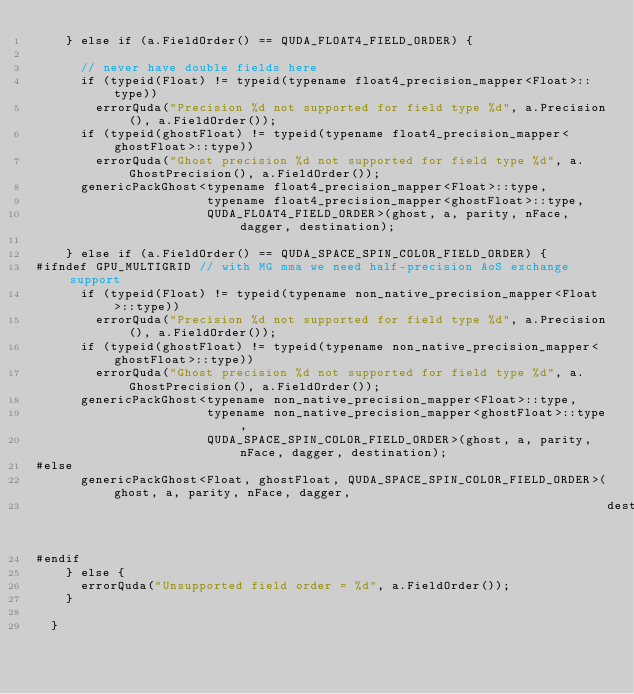<code> <loc_0><loc_0><loc_500><loc_500><_Cuda_>    } else if (a.FieldOrder() == QUDA_FLOAT4_FIELD_ORDER) {

      // never have double fields here
      if (typeid(Float) != typeid(typename float4_precision_mapper<Float>::type))
        errorQuda("Precision %d not supported for field type %d", a.Precision(), a.FieldOrder());
      if (typeid(ghostFloat) != typeid(typename float4_precision_mapper<ghostFloat>::type))
        errorQuda("Ghost precision %d not supported for field type %d", a.GhostPrecision(), a.FieldOrder());
      genericPackGhost<typename float4_precision_mapper<Float>::type,
                       typename float4_precision_mapper<ghostFloat>::type,
                       QUDA_FLOAT4_FIELD_ORDER>(ghost, a, parity, nFace, dagger, destination);

    } else if (a.FieldOrder() == QUDA_SPACE_SPIN_COLOR_FIELD_ORDER) {
#ifndef GPU_MULTIGRID // with MG mma we need half-precision AoS exchange support
      if (typeid(Float) != typeid(typename non_native_precision_mapper<Float>::type))
        errorQuda("Precision %d not supported for field type %d", a.Precision(), a.FieldOrder());
      if (typeid(ghostFloat) != typeid(typename non_native_precision_mapper<ghostFloat>::type))
        errorQuda("Ghost precision %d not supported for field type %d", a.GhostPrecision(), a.FieldOrder());
      genericPackGhost<typename non_native_precision_mapper<Float>::type,
                       typename non_native_precision_mapper<ghostFloat>::type,
                       QUDA_SPACE_SPIN_COLOR_FIELD_ORDER>(ghost, a, parity, nFace, dagger, destination);
#else
      genericPackGhost<Float, ghostFloat, QUDA_SPACE_SPIN_COLOR_FIELD_ORDER>(ghost, a, parity, nFace, dagger,
                                                                             destination);
#endif
    } else {
      errorQuda("Unsupported field order = %d", a.FieldOrder());
    }

  }
</code> 